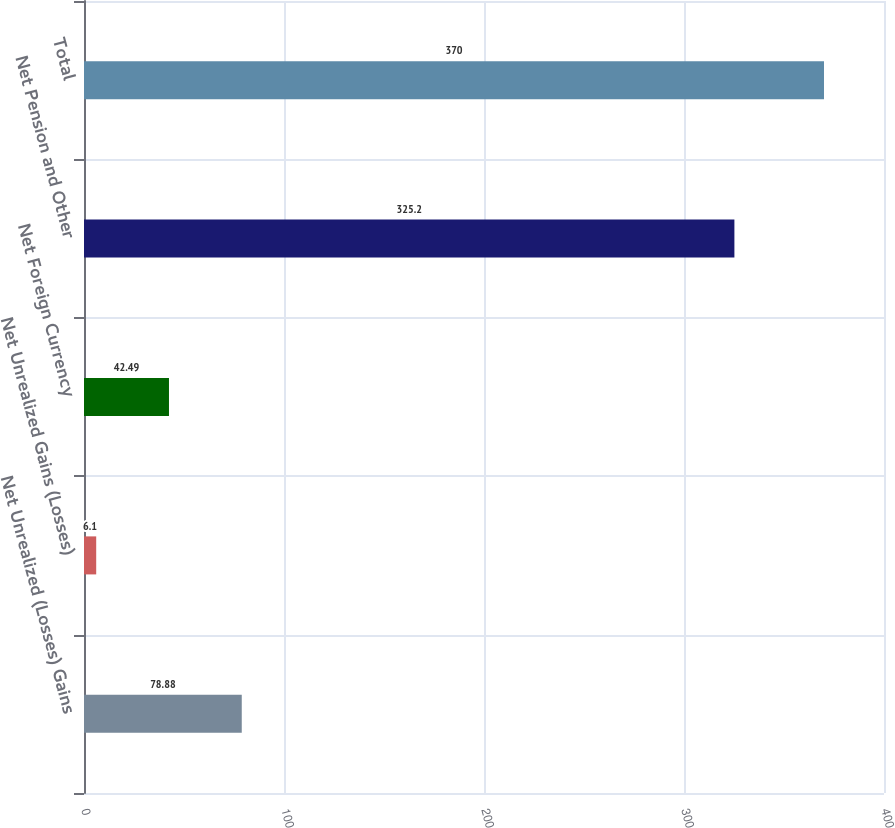Convert chart. <chart><loc_0><loc_0><loc_500><loc_500><bar_chart><fcel>Net Unrealized (Losses) Gains<fcel>Net Unrealized Gains (Losses)<fcel>Net Foreign Currency<fcel>Net Pension and Other<fcel>Total<nl><fcel>78.88<fcel>6.1<fcel>42.49<fcel>325.2<fcel>370<nl></chart> 